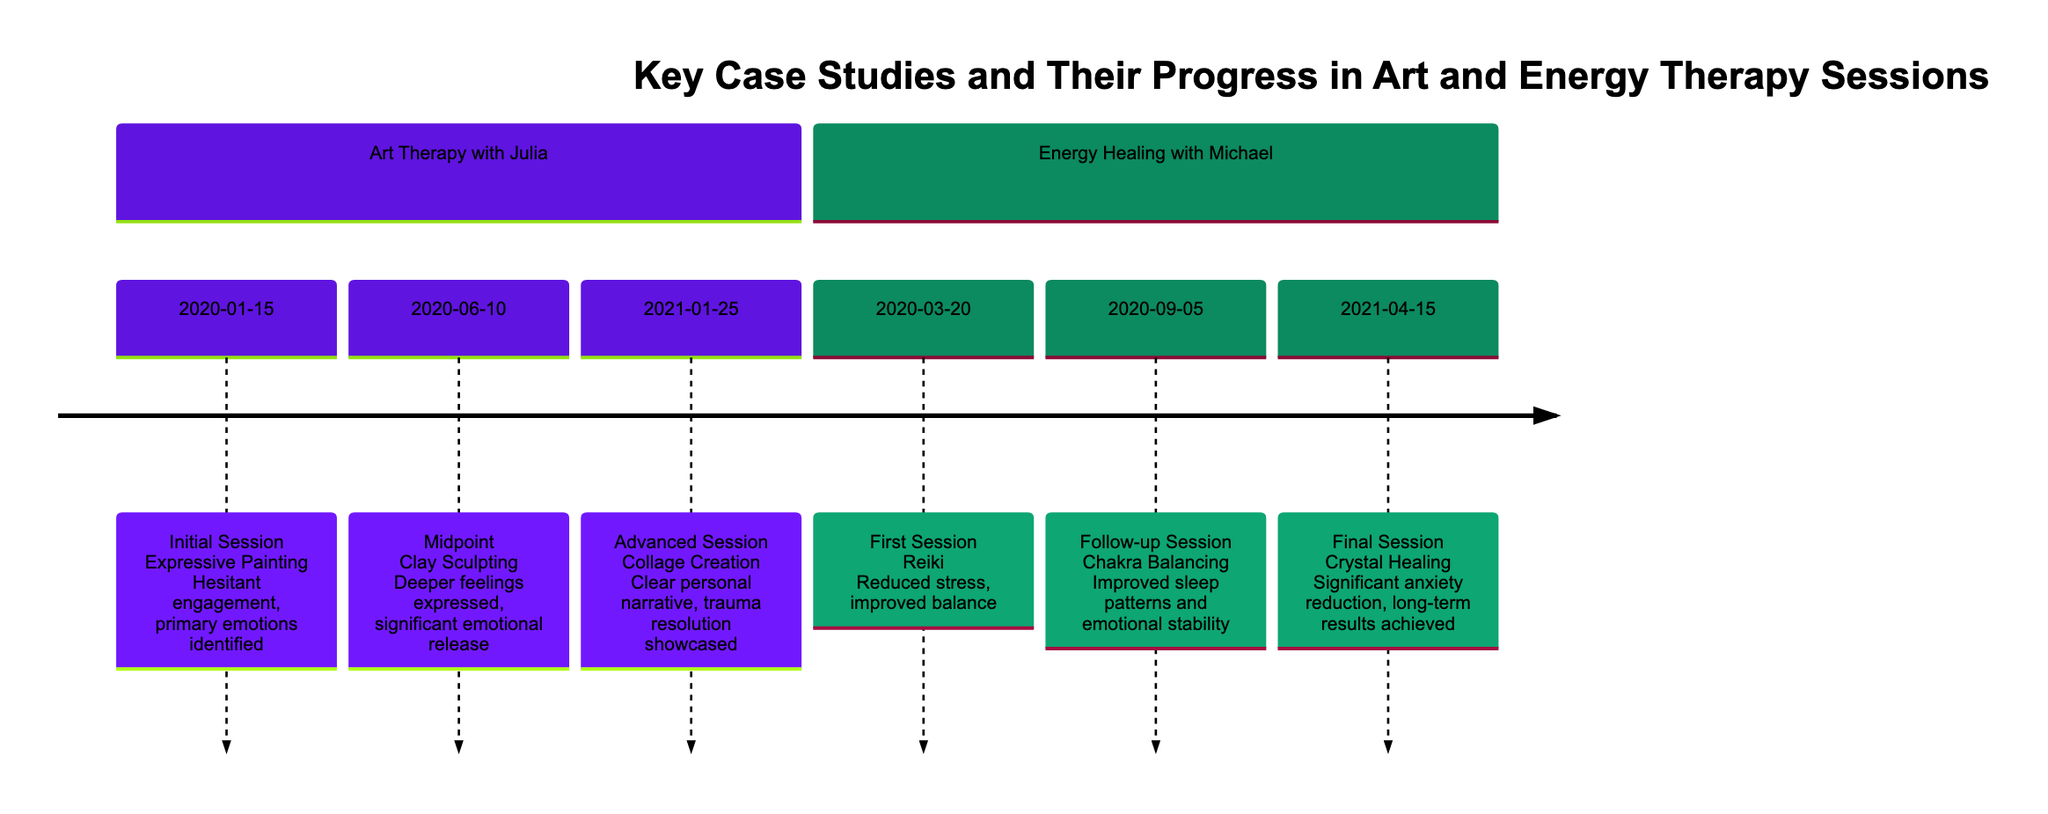What was the initial session date for Art Therapy with Julia? The diagram shows the entry for Art Therapy with Julia, specifically the initial session on January 15, 2020.
Answer: January 15, 2020 What therapy focus was used in Michael's first session? Looking at the timeline, Michael's first session focused on Reiki, as indicated under the Energy Healing section on March 20, 2020.
Answer: Reiki What significant improvement did Michael report after the Chakra Balancing session? The diagram shows that after the Chakra Balancing session on September 5, 2020, Michael reported an improvement in sleep patterns and emotional stability, as noted in the progress information.
Answer: Sleep patterns and emotional stability Which therapy session showcased trauma resolution for Julia? The diagram displays that the advanced session of Art Therapy with Julia, dated January 25, 2021, involved collage creation and showcased trauma resolution, as stated in the progress.
Answer: Collage Creation Which case study received energy work focusing on Crystal Healing last? Referring to the timeline, Energy Healing with Michael concluded with a session on Crystal Healing, dated April 15, 2021, marking it as the last focus for this therapy type.
Answer: Crystal Healing What was a common emotional issue addressed in Julia's therapy sessions? Throughout Julia's therapy sessions, particularly noted is her emotional release and deeper feelings expressed, suggesting that her emotional hesitance and trauma were common issues addressed across multiple sessions.
Answer: Emotional release How many therapy sessions are documented for Julia? The timeline includes three documented therapy sessions for Julia: Initial Session, Midpoint, and Advanced Session, making a total of three therapy sessions.
Answer: Three What therapy focus did Julia use during her midpoint session? The midpoint session for Julia, dated June 10, 2020, focused on Clay Sculpting, as indicated under Art Therapy with Julia in the diagram.
Answer: Clay Sculpting What was the overall progress Michael achieved by the final energy therapy session? By the final energy therapy session on April 15, 2021, Michael achieved a significant reduction in anxiety levels and experienced long-term results, which is noted in the progress update for that session.
Answer: Significant anxiety reduction 